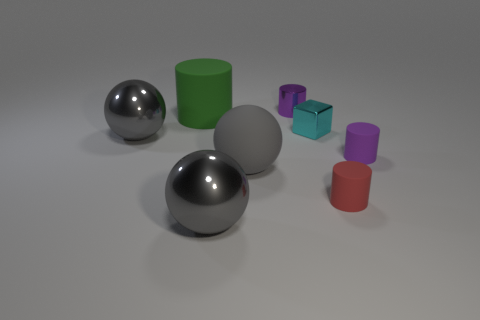Is there anything else that is the same size as the green object?
Keep it short and to the point. Yes. How many objects are shiny cubes or matte cylinders that are right of the large cylinder?
Your response must be concise. 3. The gray ball that is made of the same material as the large cylinder is what size?
Keep it short and to the point. Large. What is the shape of the large matte thing to the left of the big gray shiny object that is in front of the large gray matte thing?
Offer a very short reply. Cylinder. What size is the cylinder that is both on the right side of the large green thing and behind the tiny purple rubber cylinder?
Your answer should be very brief. Small. Is there another red matte object of the same shape as the red thing?
Provide a short and direct response. No. Is there any other thing that has the same shape as the tiny red object?
Ensure brevity in your answer.  Yes. There is a small purple cylinder behind the gray object that is on the left side of the large cylinder on the left side of the small red thing; what is its material?
Your answer should be very brief. Metal. Are there any metal spheres that have the same size as the purple metal cylinder?
Provide a succinct answer. No. There is a small shiny thing that is right of the purple cylinder behind the shiny cube; what is its color?
Your response must be concise. Cyan. 